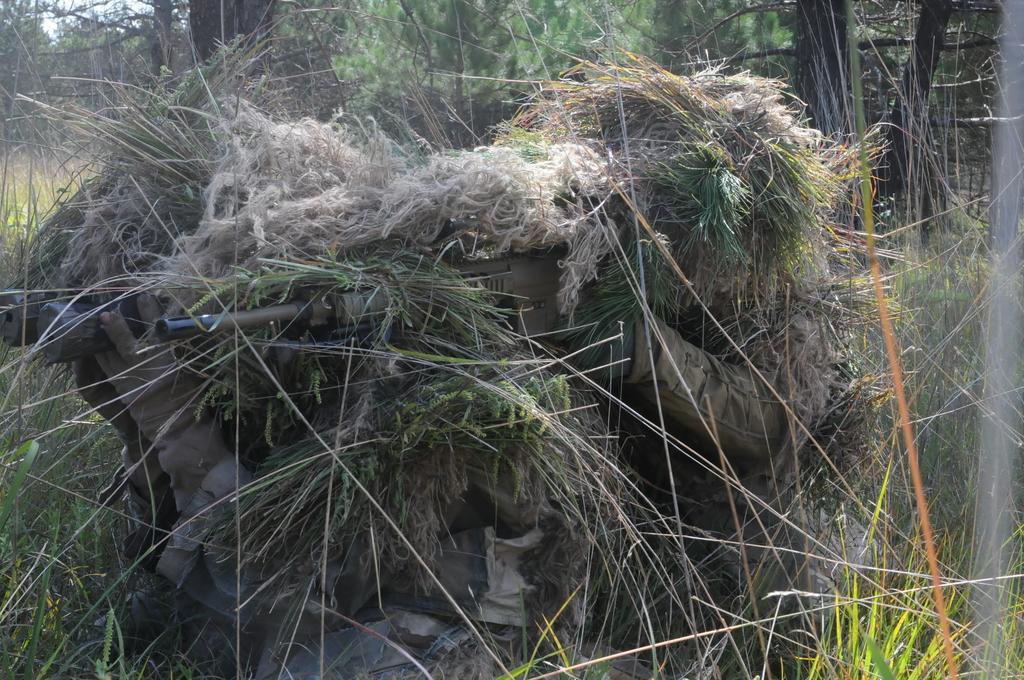In one or two sentences, can you explain what this image depicts? In this image we can see persons holding gun and binocular. And they are covered with grass. In the background there are trees. 